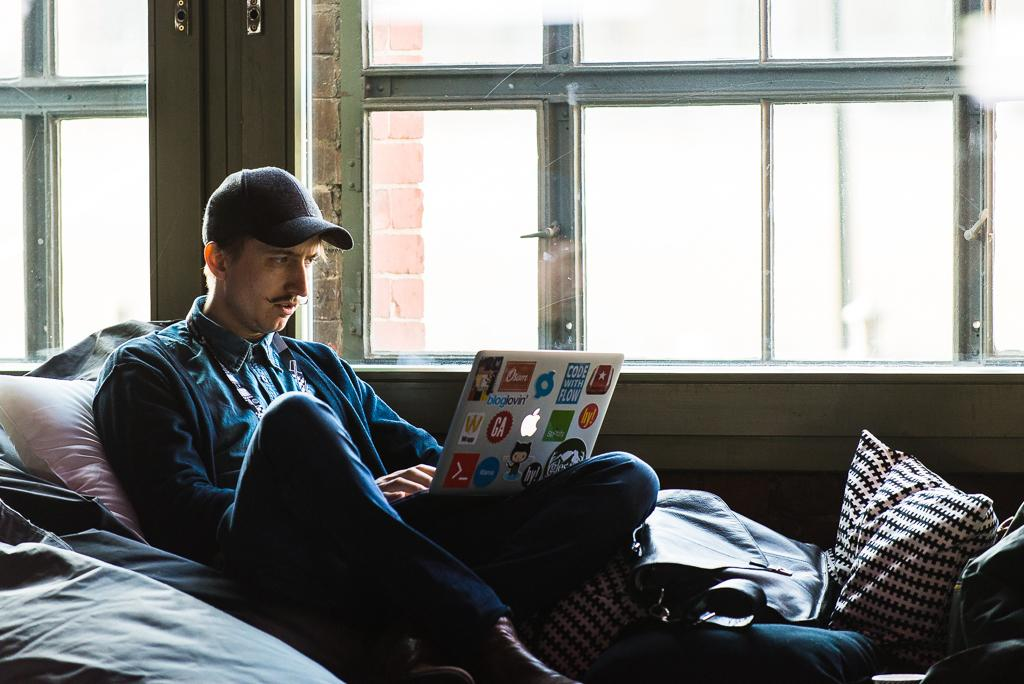What is the main subject of the image? There is a person in the image. What is the person wearing on their head? The person is wearing a cap. What is the person doing in the image? The person is sitting and operating a laptop. What can be seen beside the person? There is a glass window beside the person. What object is present in the right corner of the image? There is a pillow in the right corner of the image. What type of earth can be seen growing in the image? There is no earth or growth visible in the image; it features a person sitting and operating a laptop. 